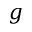<formula> <loc_0><loc_0><loc_500><loc_500>g</formula> 